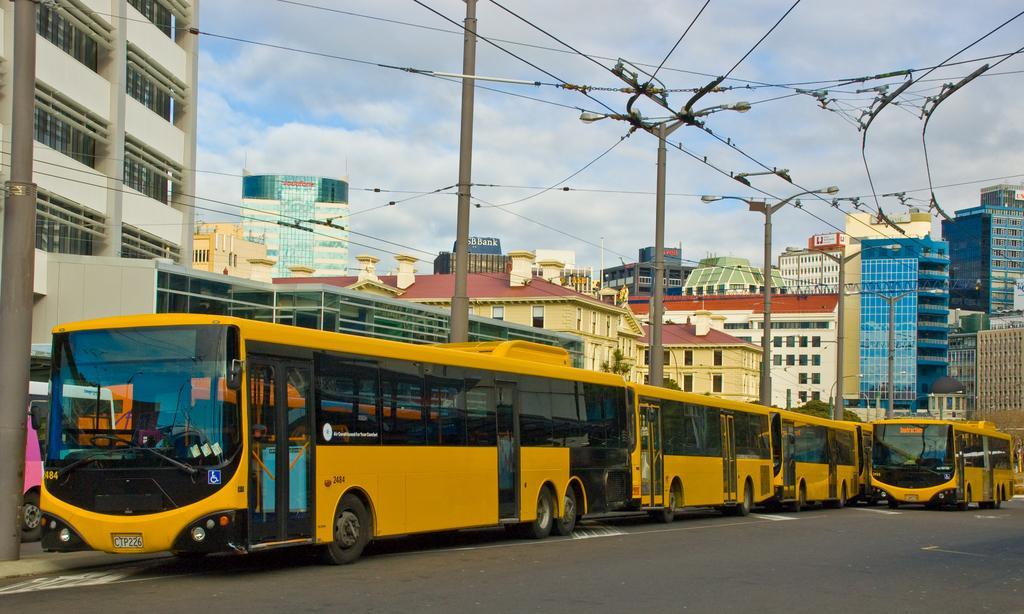Can you describe this image briefly? In this image I can see the road, few buses which are yellow and black in color on the road, few poles, few wires and few buildings. In the background I can see the sky. 